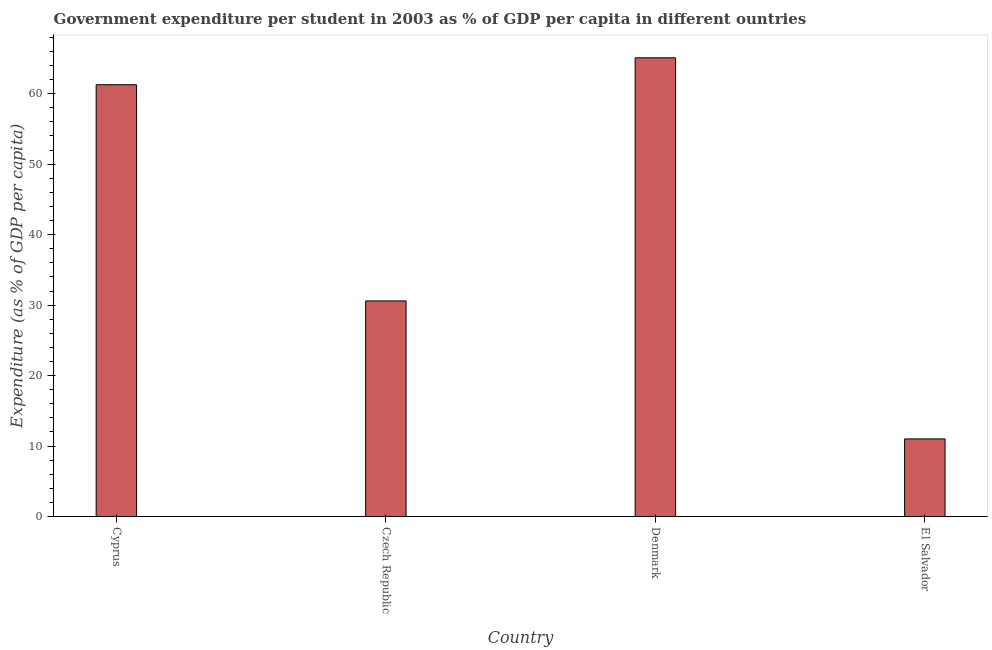Does the graph contain grids?
Ensure brevity in your answer.  No. What is the title of the graph?
Provide a short and direct response. Government expenditure per student in 2003 as % of GDP per capita in different ountries. What is the label or title of the X-axis?
Offer a very short reply. Country. What is the label or title of the Y-axis?
Keep it short and to the point. Expenditure (as % of GDP per capita). What is the government expenditure per student in Czech Republic?
Offer a terse response. 30.59. Across all countries, what is the maximum government expenditure per student?
Give a very brief answer. 65.09. Across all countries, what is the minimum government expenditure per student?
Ensure brevity in your answer.  11.01. In which country was the government expenditure per student maximum?
Make the answer very short. Denmark. In which country was the government expenditure per student minimum?
Your answer should be compact. El Salvador. What is the sum of the government expenditure per student?
Your answer should be compact. 167.97. What is the difference between the government expenditure per student in Cyprus and Czech Republic?
Make the answer very short. 30.68. What is the average government expenditure per student per country?
Make the answer very short. 41.99. What is the median government expenditure per student?
Keep it short and to the point. 45.93. In how many countries, is the government expenditure per student greater than 8 %?
Give a very brief answer. 4. What is the ratio of the government expenditure per student in Cyprus to that in Denmark?
Make the answer very short. 0.94. Is the government expenditure per student in Denmark less than that in El Salvador?
Your answer should be very brief. No. Is the difference between the government expenditure per student in Czech Republic and El Salvador greater than the difference between any two countries?
Give a very brief answer. No. What is the difference between the highest and the second highest government expenditure per student?
Your answer should be very brief. 3.82. What is the difference between the highest and the lowest government expenditure per student?
Keep it short and to the point. 54.09. How many bars are there?
Provide a succinct answer. 4. How many countries are there in the graph?
Offer a terse response. 4. What is the difference between two consecutive major ticks on the Y-axis?
Keep it short and to the point. 10. Are the values on the major ticks of Y-axis written in scientific E-notation?
Offer a terse response. No. What is the Expenditure (as % of GDP per capita) in Cyprus?
Offer a very short reply. 61.27. What is the Expenditure (as % of GDP per capita) in Czech Republic?
Provide a short and direct response. 30.59. What is the Expenditure (as % of GDP per capita) of Denmark?
Provide a succinct answer. 65.09. What is the Expenditure (as % of GDP per capita) in El Salvador?
Provide a succinct answer. 11.01. What is the difference between the Expenditure (as % of GDP per capita) in Cyprus and Czech Republic?
Make the answer very short. 30.68. What is the difference between the Expenditure (as % of GDP per capita) in Cyprus and Denmark?
Your answer should be compact. -3.82. What is the difference between the Expenditure (as % of GDP per capita) in Cyprus and El Salvador?
Ensure brevity in your answer.  50.26. What is the difference between the Expenditure (as % of GDP per capita) in Czech Republic and Denmark?
Keep it short and to the point. -34.5. What is the difference between the Expenditure (as % of GDP per capita) in Czech Republic and El Salvador?
Keep it short and to the point. 19.58. What is the difference between the Expenditure (as % of GDP per capita) in Denmark and El Salvador?
Offer a very short reply. 54.09. What is the ratio of the Expenditure (as % of GDP per capita) in Cyprus to that in Czech Republic?
Your answer should be very brief. 2. What is the ratio of the Expenditure (as % of GDP per capita) in Cyprus to that in Denmark?
Keep it short and to the point. 0.94. What is the ratio of the Expenditure (as % of GDP per capita) in Cyprus to that in El Salvador?
Your response must be concise. 5.57. What is the ratio of the Expenditure (as % of GDP per capita) in Czech Republic to that in Denmark?
Offer a terse response. 0.47. What is the ratio of the Expenditure (as % of GDP per capita) in Czech Republic to that in El Salvador?
Your answer should be compact. 2.78. What is the ratio of the Expenditure (as % of GDP per capita) in Denmark to that in El Salvador?
Your answer should be very brief. 5.91. 